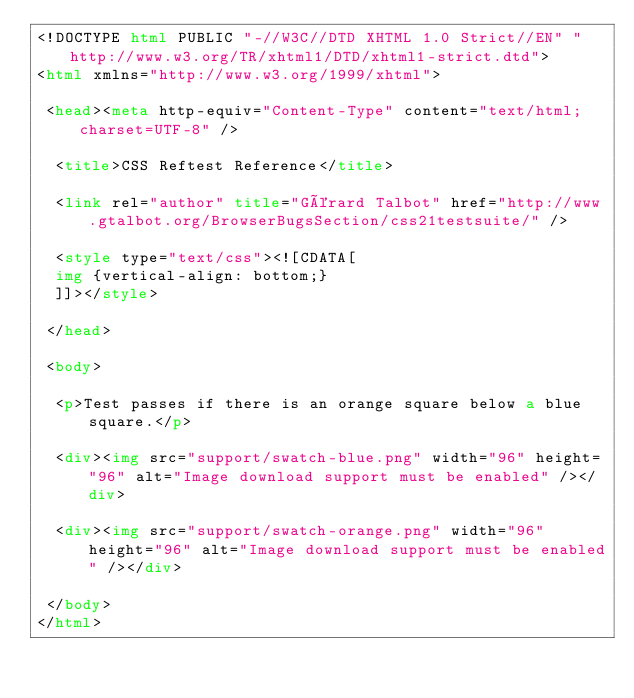Convert code to text. <code><loc_0><loc_0><loc_500><loc_500><_HTML_><!DOCTYPE html PUBLIC "-//W3C//DTD XHTML 1.0 Strict//EN" "http://www.w3.org/TR/xhtml1/DTD/xhtml1-strict.dtd">
<html xmlns="http://www.w3.org/1999/xhtml">

 <head><meta http-equiv="Content-Type" content="text/html; charset=UTF-8" />

  <title>CSS Reftest Reference</title>

  <link rel="author" title="Gérard Talbot" href="http://www.gtalbot.org/BrowserBugsSection/css21testsuite/" />

  <style type="text/css"><![CDATA[
  img {vertical-align: bottom;}
  ]]></style>

 </head>

 <body>

  <p>Test passes if there is an orange square below a blue square.</p>

  <div><img src="support/swatch-blue.png" width="96" height="96" alt="Image download support must be enabled" /></div>

  <div><img src="support/swatch-orange.png" width="96" height="96" alt="Image download support must be enabled" /></div>

 </body>
</html></code> 